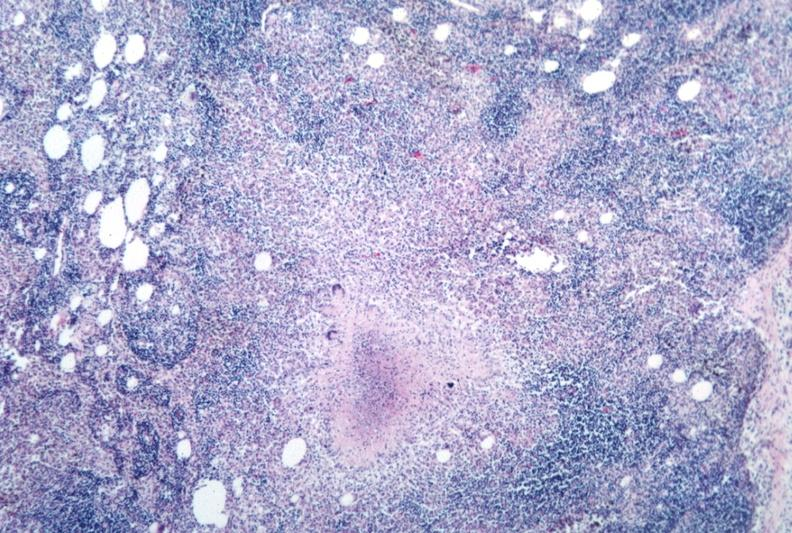s lymph node present?
Answer the question using a single word or phrase. Yes 